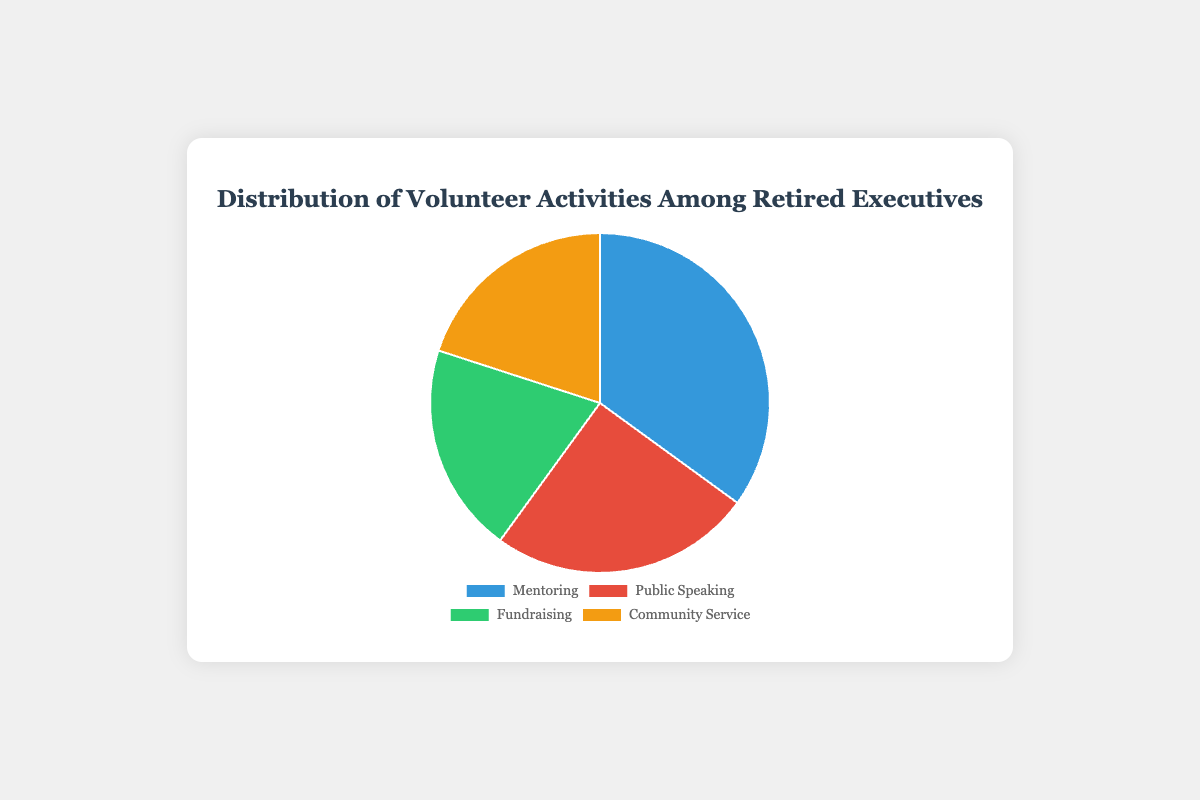What is the most common volunteer activity among retired executives? By looking at the chart, we can see which segment has the largest portion of the pie. The "Mentoring" segment is the largest.
Answer: Mentoring Which two activities have an equal percentage of volunteers? By examining the pie chart, we see that "Fundraising" and "Community Service" both have the same size segment, which represents 20%.
Answer: Fundraising and Community Service What is the total percentage of retired executives involved in Fundraising and Community Service? To find the total percentage, we sum the percentages of "Fundraising" and "Community Service." Each activity has 20%, so the total is 20% + 20% = 40%.
Answer: 40% How much greater is the percentage of executives involved in Mentoring compared to those in Public Speaking? The percentage of Mentoring is 35% and Public Speaking is 25%. The difference is 35% - 25% = 10%.
Answer: 10% How does the distribution of retired executives in Public Speaking compare to those in Community Service? Both have different percentages. Public Speaking has 25%, while Community Service has 20%. Hence, Public Speaking has a larger share.
Answer: Public Speaking is greater Which activity has the smallest share of volunteer involvement? By examining the chart, the smallest segments are those of "Fundraising" and "Community Service" at 20%.
Answer: Fundraising and Community Service If we combine Mentoring and Public Speaking, what is their combined percentage of volunteer activities? The combined percentage is calculated by adding their individual percentages: 35% for Mentoring and 25% for Public Speaking, so 35% + 25% = 60%.
Answer: 60% What color represents Fundraising in the pie chart? By looking at the color of the segment labeled "Fundraising," it is represented by the green segment.
Answer: Green Which volunteer activity has 25% representation? By checking the percentages associated with each segment, "Public Speaking" has 25% representation.
Answer: Public Speaking If you removed Mentoring from the chart, what would be the new total percentage of the remaining activities? Mentoring represents 35%. By removing it, the remaining activities' percentages are 25% (Public Speaking) + 20% (Fundraising) + 20% (Community Service) = 65%.
Answer: 65% 